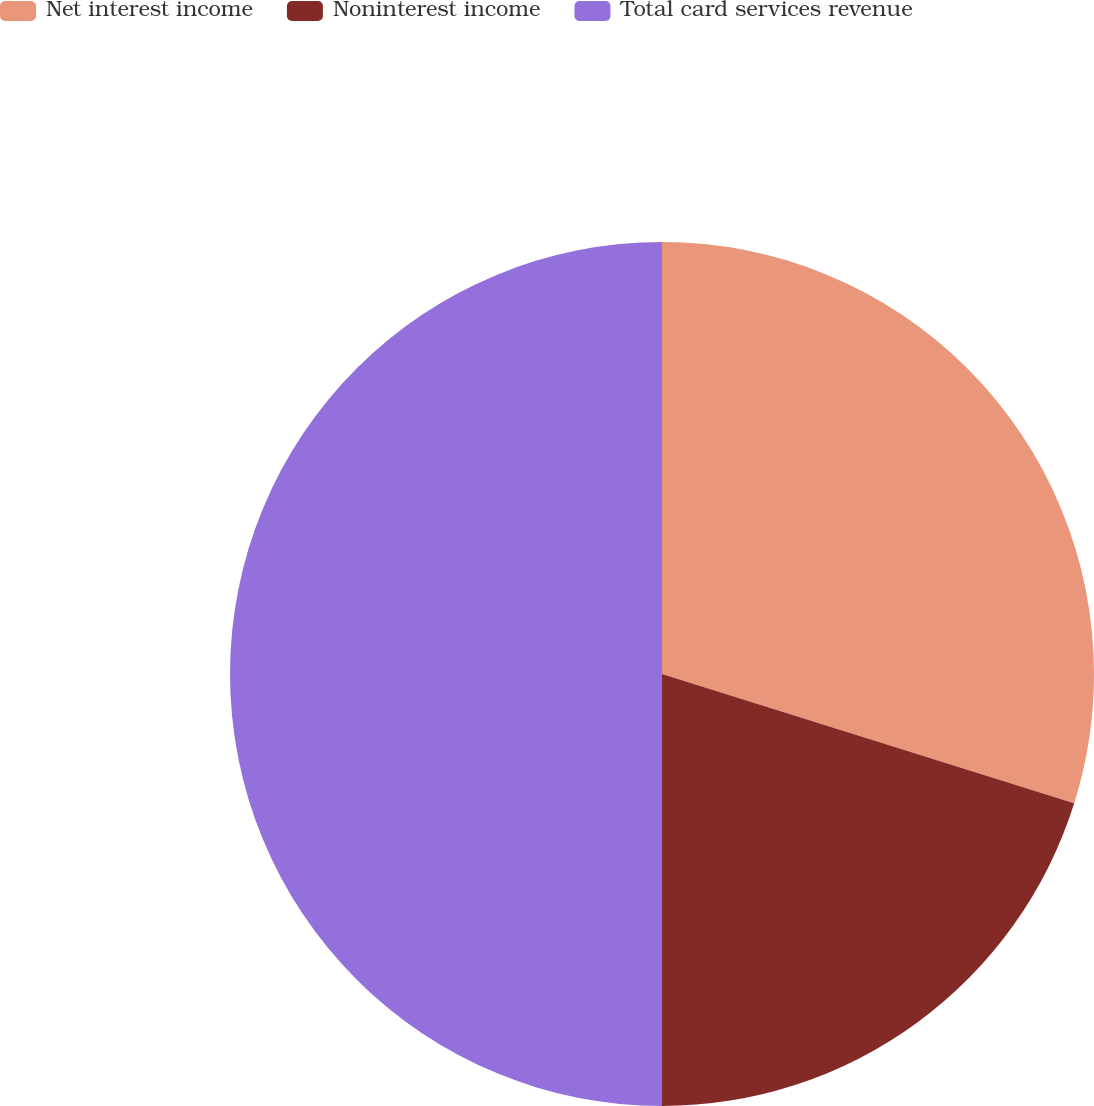Convert chart. <chart><loc_0><loc_0><loc_500><loc_500><pie_chart><fcel>Net interest income<fcel>Noninterest income<fcel>Total card services revenue<nl><fcel>29.84%<fcel>20.16%<fcel>50.0%<nl></chart> 